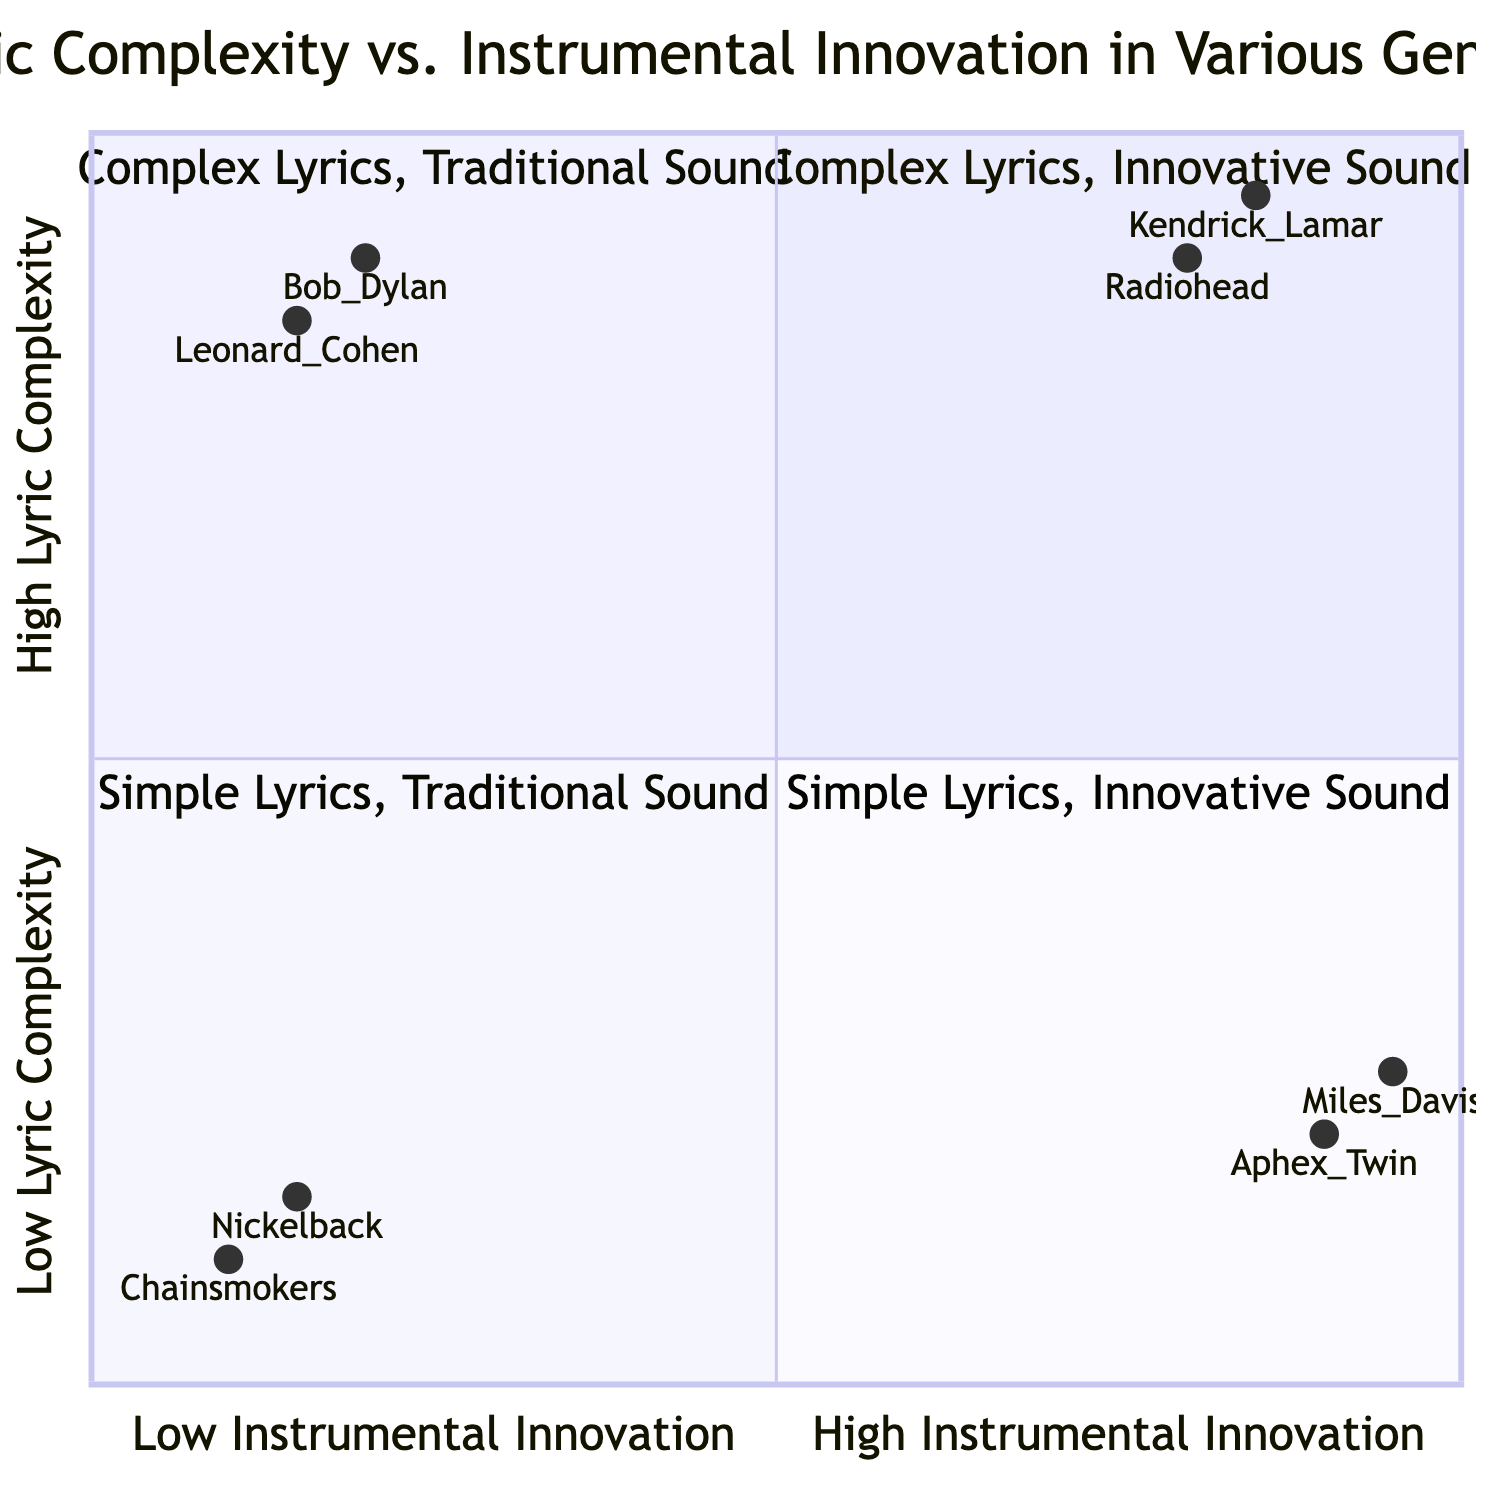What artists are in the "High Lyric Complexity, High Instrumental Innovation" quadrant? The quadrant represented includes artists with both high lyric complexity and high instrumental innovation. These artists are Radiohead and Kendrick Lamar, as listed in the data.
Answer: Radiohead, Kendrick Lamar Which genre has the most artists in the "Low Lyric Complexity, Low Instrumental Innovation" quadrant? The artists in this quadrant are Chainsmokers and Nickelback, both classified under Pop and Post-Grunge genres respectively. Since only two artists are listed in this quadrant, there is no predominant genre, but they collectively belong to mainstream music categories.
Answer: Pop, Post-Grunge How many artists have "High Lyric Complexity" according to the diagram? The diagram lists four artists overall, but only Radiohead and Kendrick Lamar are in the "High Lyric Complexity" categories. Therefore, we count two artists who exhibit high lyric complexity in their music.
Answer: 2 Which artist has the highest instrumental innovation? The artist with the highest instrumental innovation is Miles Davis, positioned at 0.95 in the diagram, which signals high innovation in instrumental music.
Answer: Miles Davis In which quadrant would you find Aphex Twin? Aphex Twin is located in the "Low Lyric Complexity, High Instrumental Innovation" quadrant, indicated by the combination of a low score for lyric complexity and a high score for instrumental innovation.
Answer: Low Lyric Complexity, High Instrumental Innovation Which artist is furthest to the right in the diagram? The artist furthest to the right, indicating the highest instrumental innovation, is Aphex Twin with a coordinate value of 0.9, showcasing significant innovation as emphasized in the diagram.
Answer: Aphex Twin What can be inferred about the lyric complexity of Chainsmokers? The Chainsmokers, categorized in the "Low Lyric Complexity, Low Instrumental Innovation" quadrant, indicate a relatively simple lyrical approach in their music style, according to the provided data.
Answer: Low Lyric Complexity Which artist illustrates complex lyrics but a traditional sound? Bob Dylan exemplifies complex lyrics and a traditional sound, occupying the "High Lyric Complexity, Low Instrumental Innovation" quadrant on the chart, as established by the pairing of high lyrical depth and lower instrumental progression.
Answer: Bob Dylan 